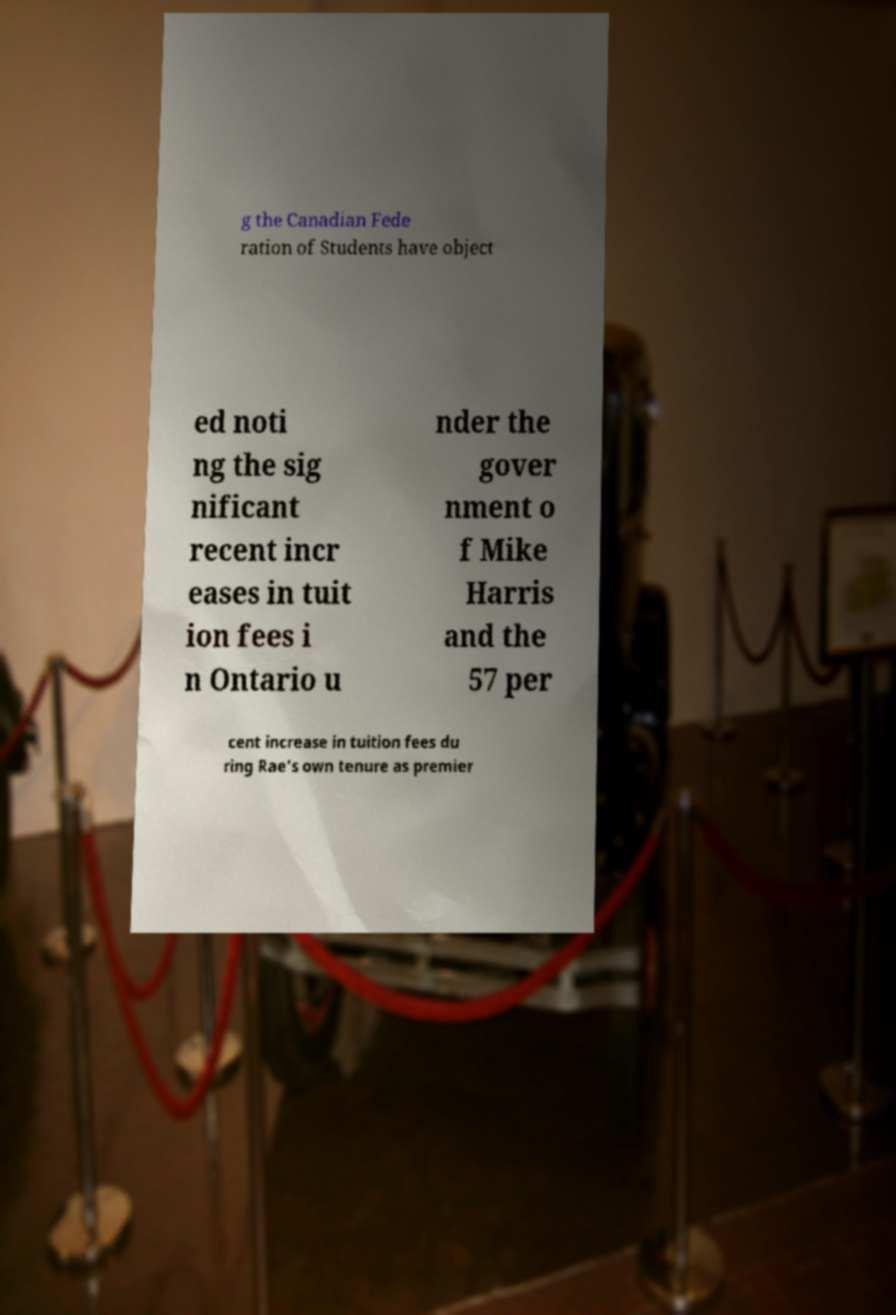Can you accurately transcribe the text from the provided image for me? g the Canadian Fede ration of Students have object ed noti ng the sig nificant recent incr eases in tuit ion fees i n Ontario u nder the gover nment o f Mike Harris and the 57 per cent increase in tuition fees du ring Rae's own tenure as premier 